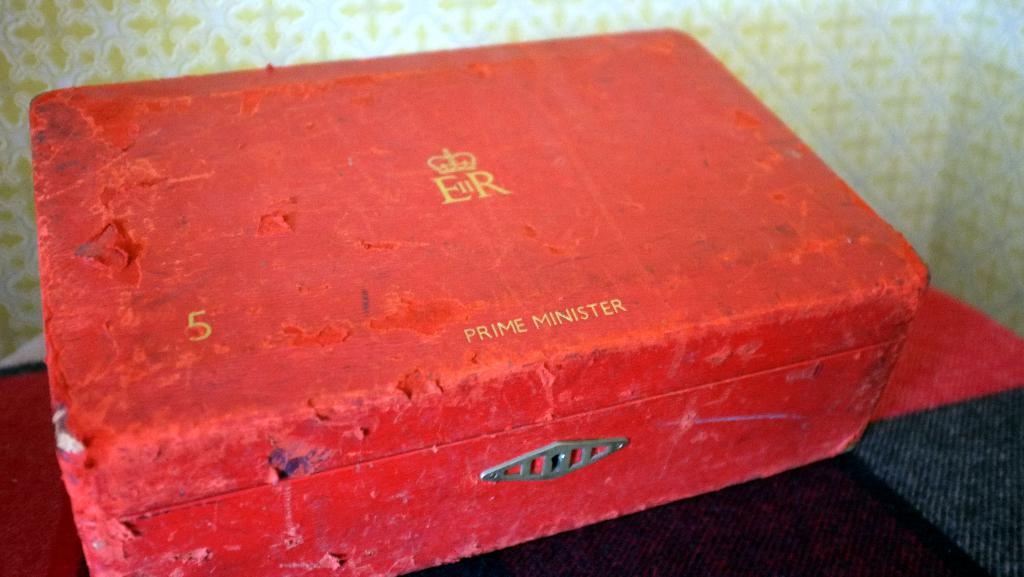What does it say in the bottom right corner?
Give a very brief answer. Prime minister. 